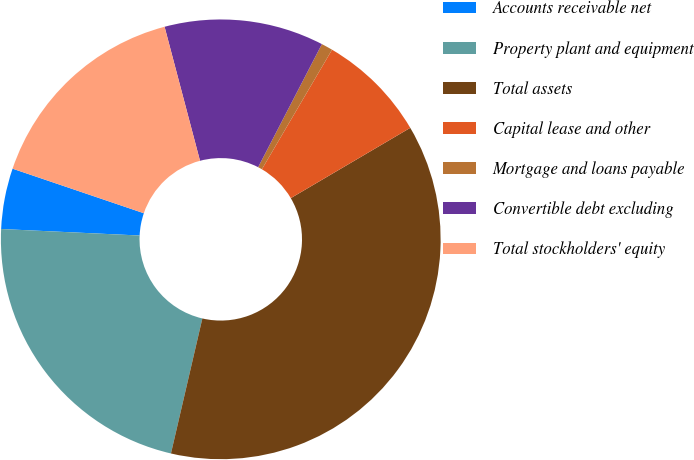<chart> <loc_0><loc_0><loc_500><loc_500><pie_chart><fcel>Accounts receivable net<fcel>Property plant and equipment<fcel>Total assets<fcel>Capital lease and other<fcel>Mortgage and loans payable<fcel>Convertible debt excluding<fcel>Total stockholders' equity<nl><fcel>4.46%<fcel>22.11%<fcel>37.1%<fcel>8.09%<fcel>0.84%<fcel>11.72%<fcel>15.68%<nl></chart> 